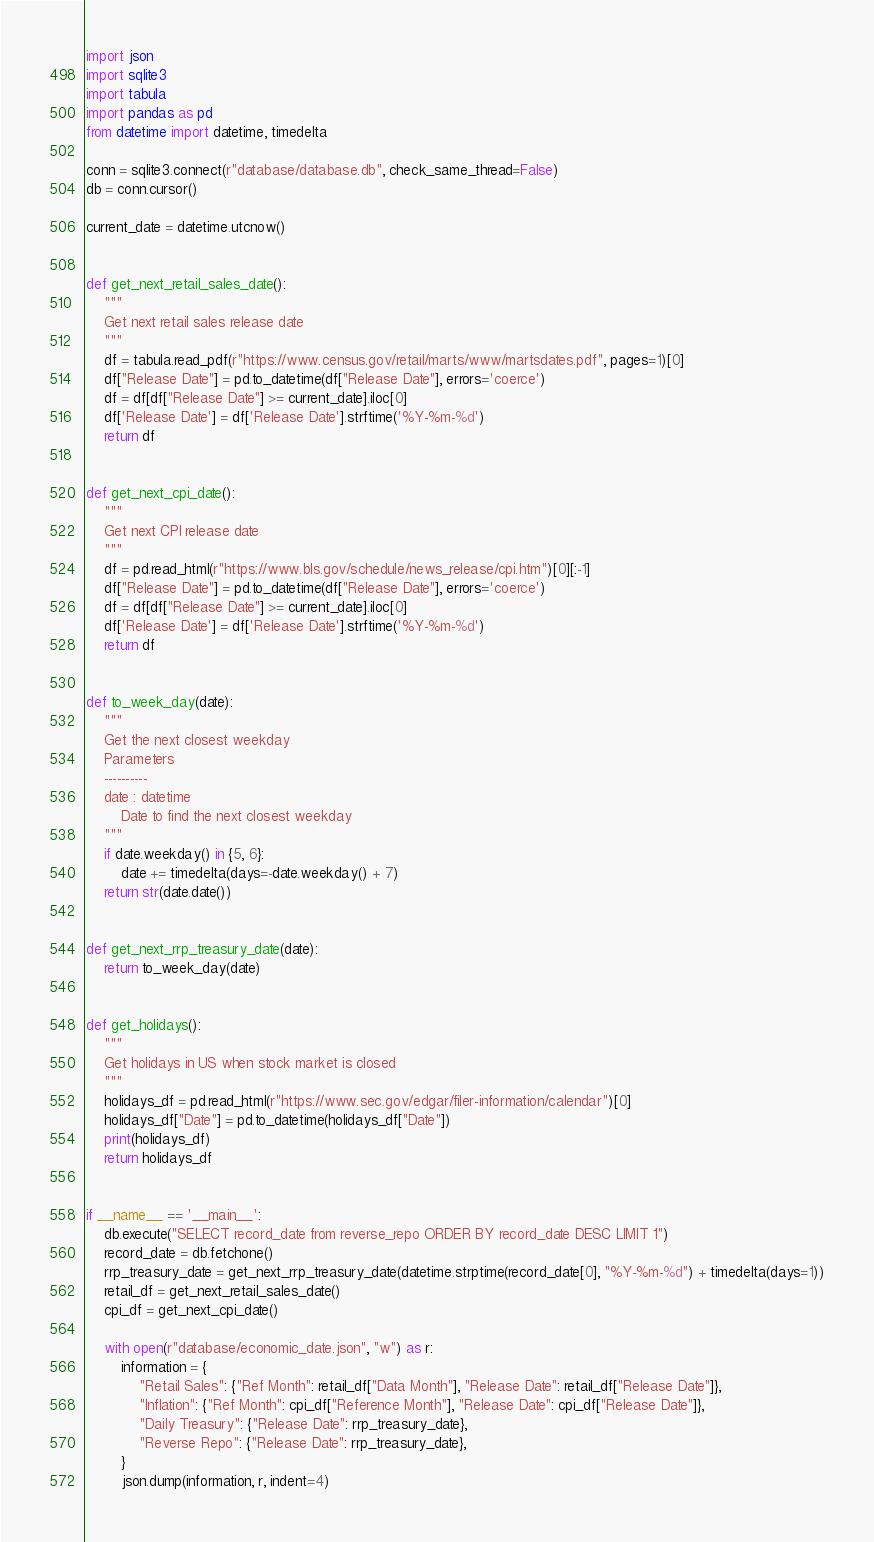<code> <loc_0><loc_0><loc_500><loc_500><_Python_>import json
import sqlite3
import tabula
import pandas as pd
from datetime import datetime, timedelta

conn = sqlite3.connect(r"database/database.db", check_same_thread=False)
db = conn.cursor()

current_date = datetime.utcnow()


def get_next_retail_sales_date():
    """
    Get next retail sales release date
    """
    df = tabula.read_pdf(r"https://www.census.gov/retail/marts/www/martsdates.pdf", pages=1)[0]
    df["Release Date"] = pd.to_datetime(df["Release Date"], errors='coerce')
    df = df[df["Release Date"] >= current_date].iloc[0]
    df['Release Date'] = df['Release Date'].strftime('%Y-%m-%d')
    return df


def get_next_cpi_date():
    """
    Get next CPI release date
    """
    df = pd.read_html(r"https://www.bls.gov/schedule/news_release/cpi.htm")[0][:-1]
    df["Release Date"] = pd.to_datetime(df["Release Date"], errors='coerce')
    df = df[df["Release Date"] >= current_date].iloc[0]
    df['Release Date'] = df['Release Date'].strftime('%Y-%m-%d')
    return df


def to_week_day(date):
    """
    Get the next closest weekday
    Parameters
    ----------
    date : datetime
        Date to find the next closest weekday
    """
    if date.weekday() in {5, 6}:
        date += timedelta(days=-date.weekday() + 7)
    return str(date.date())


def get_next_rrp_treasury_date(date):
    return to_week_day(date)


def get_holidays():
    """
    Get holidays in US when stock market is closed
    """
    holidays_df = pd.read_html(r"https://www.sec.gov/edgar/filer-information/calendar")[0]
    holidays_df["Date"] = pd.to_datetime(holidays_df["Date"])
    print(holidays_df)
    return holidays_df


if __name__ == '__main__':
    db.execute("SELECT record_date from reverse_repo ORDER BY record_date DESC LIMIT 1")
    record_date = db.fetchone()
    rrp_treasury_date = get_next_rrp_treasury_date(datetime.strptime(record_date[0], "%Y-%m-%d") + timedelta(days=1))
    retail_df = get_next_retail_sales_date()
    cpi_df = get_next_cpi_date()

    with open(r"database/economic_date.json", "w") as r:
        information = {
            "Retail Sales": {"Ref Month": retail_df["Data Month"], "Release Date": retail_df["Release Date"]},
            "Inflation": {"Ref Month": cpi_df["Reference Month"], "Release Date": cpi_df["Release Date"]},
            "Daily Treasury": {"Release Date": rrp_treasury_date},
            "Reverse Repo": {"Release Date": rrp_treasury_date},
        }
        json.dump(information, r, indent=4)
</code> 